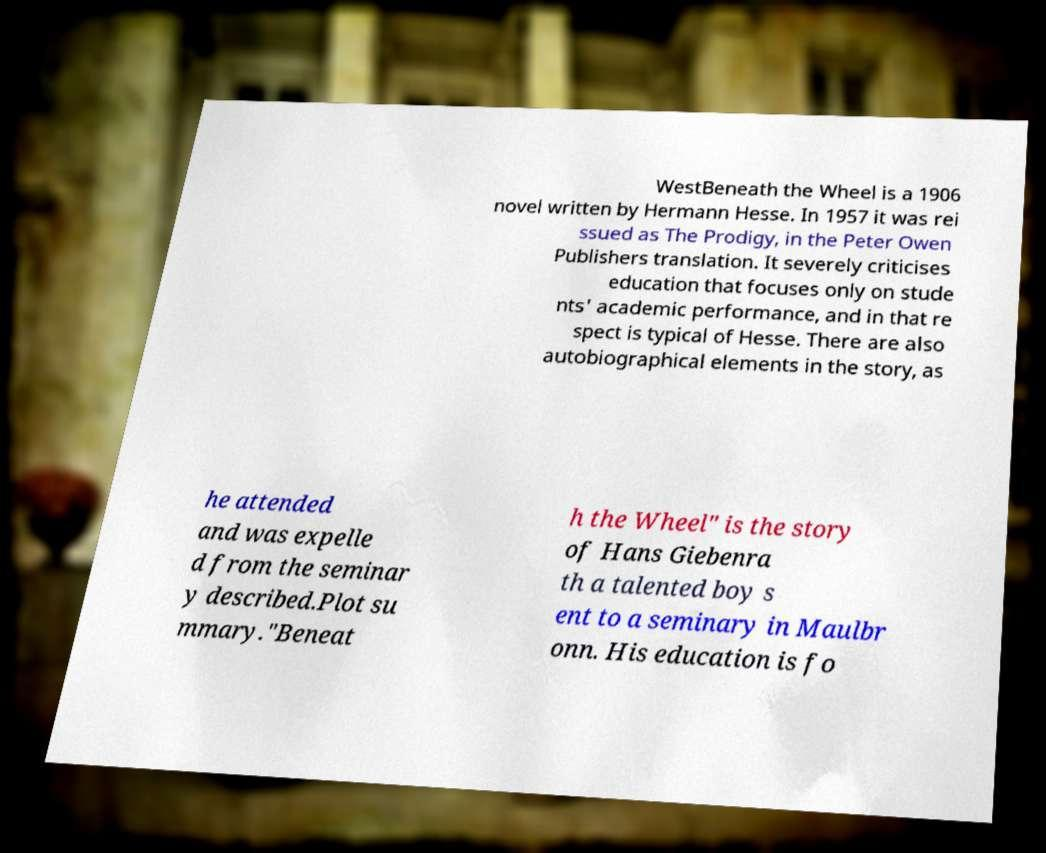Please identify and transcribe the text found in this image. WestBeneath the Wheel is a 1906 novel written by Hermann Hesse. In 1957 it was rei ssued as The Prodigy, in the Peter Owen Publishers translation. It severely criticises education that focuses only on stude nts' academic performance, and in that re spect is typical of Hesse. There are also autobiographical elements in the story, as he attended and was expelle d from the seminar y described.Plot su mmary."Beneat h the Wheel" is the story of Hans Giebenra th a talented boy s ent to a seminary in Maulbr onn. His education is fo 